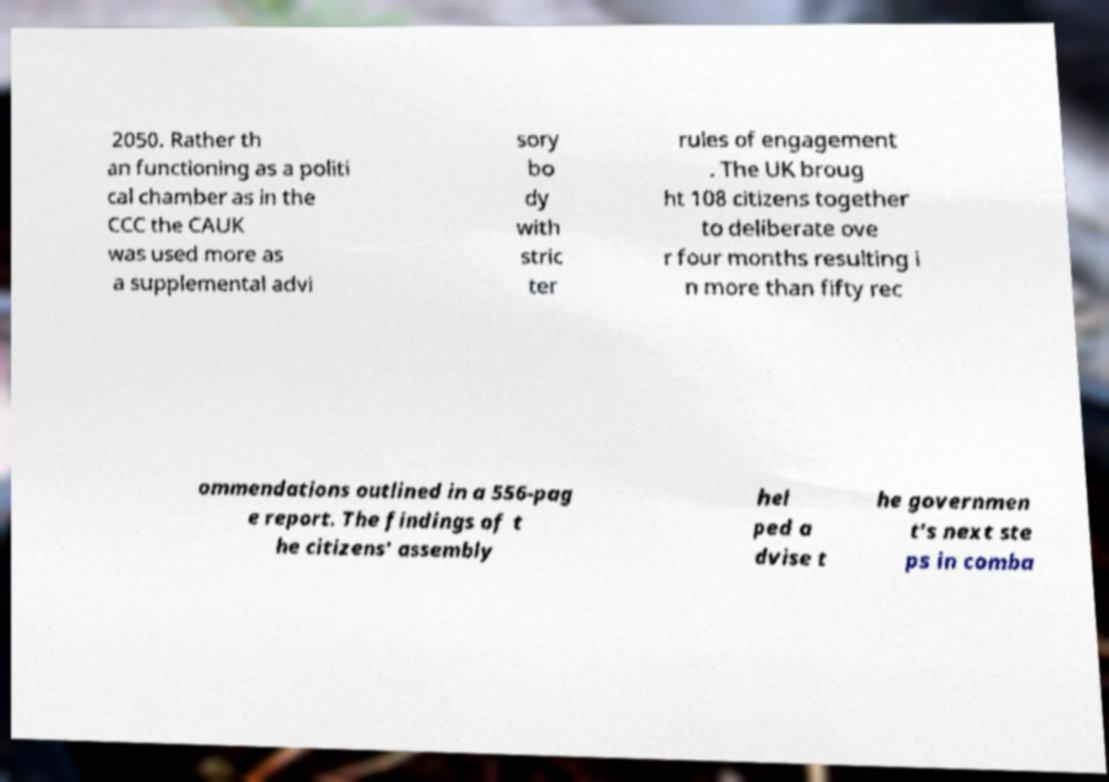Can you read and provide the text displayed in the image?This photo seems to have some interesting text. Can you extract and type it out for me? 2050. Rather th an functioning as a politi cal chamber as in the CCC the CAUK was used more as a supplemental advi sory bo dy with stric ter rules of engagement . The UK broug ht 108 citizens together to deliberate ove r four months resulting i n more than fifty rec ommendations outlined in a 556-pag e report. The findings of t he citizens' assembly hel ped a dvise t he governmen t's next ste ps in comba 